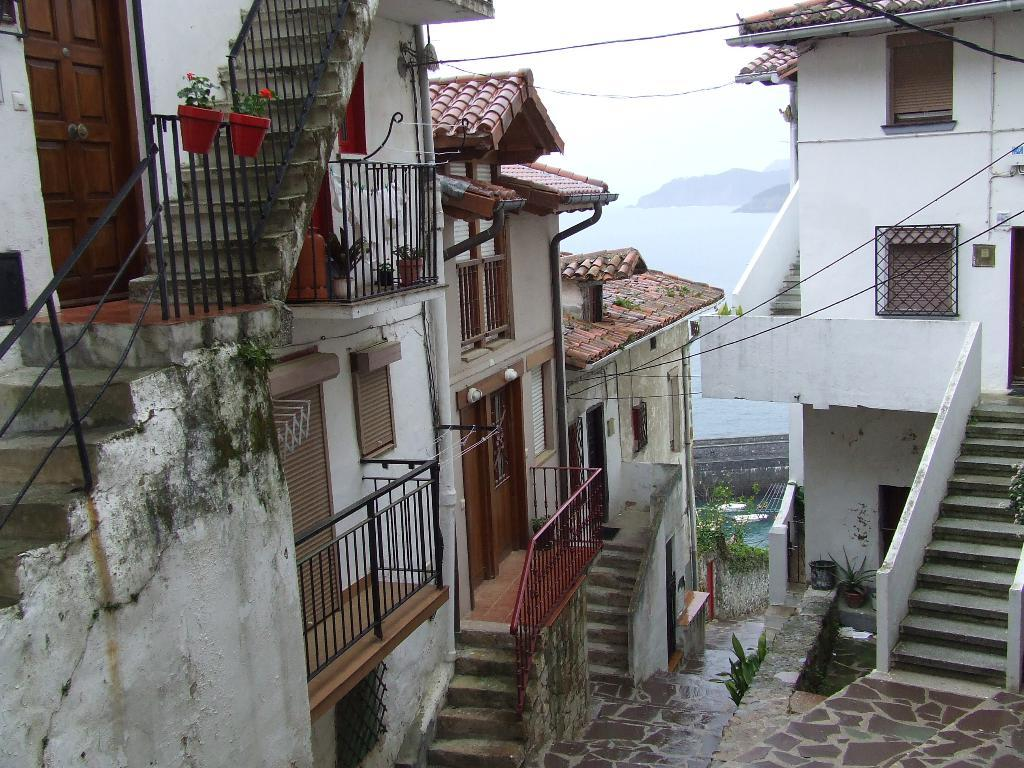What type of living organisms can be seen in the image? Plants can be seen in the image. What type of structures are present in the image? There are houses in the image. What architectural features can be seen on the houses? There are doors and windows visible on the houses. What can be seen in the background of the image? Water and the sky are visible in the background of the image. What language are the plants communicating in the image? Plants do not communicate using language, so this cannot be determined from the image. 